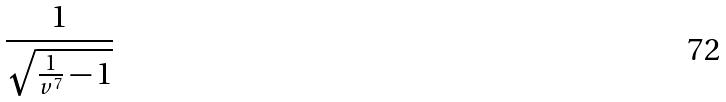Convert formula to latex. <formula><loc_0><loc_0><loc_500><loc_500>\frac { 1 } { \sqrt { \frac { 1 } { v ^ { 7 } } - 1 } }</formula> 